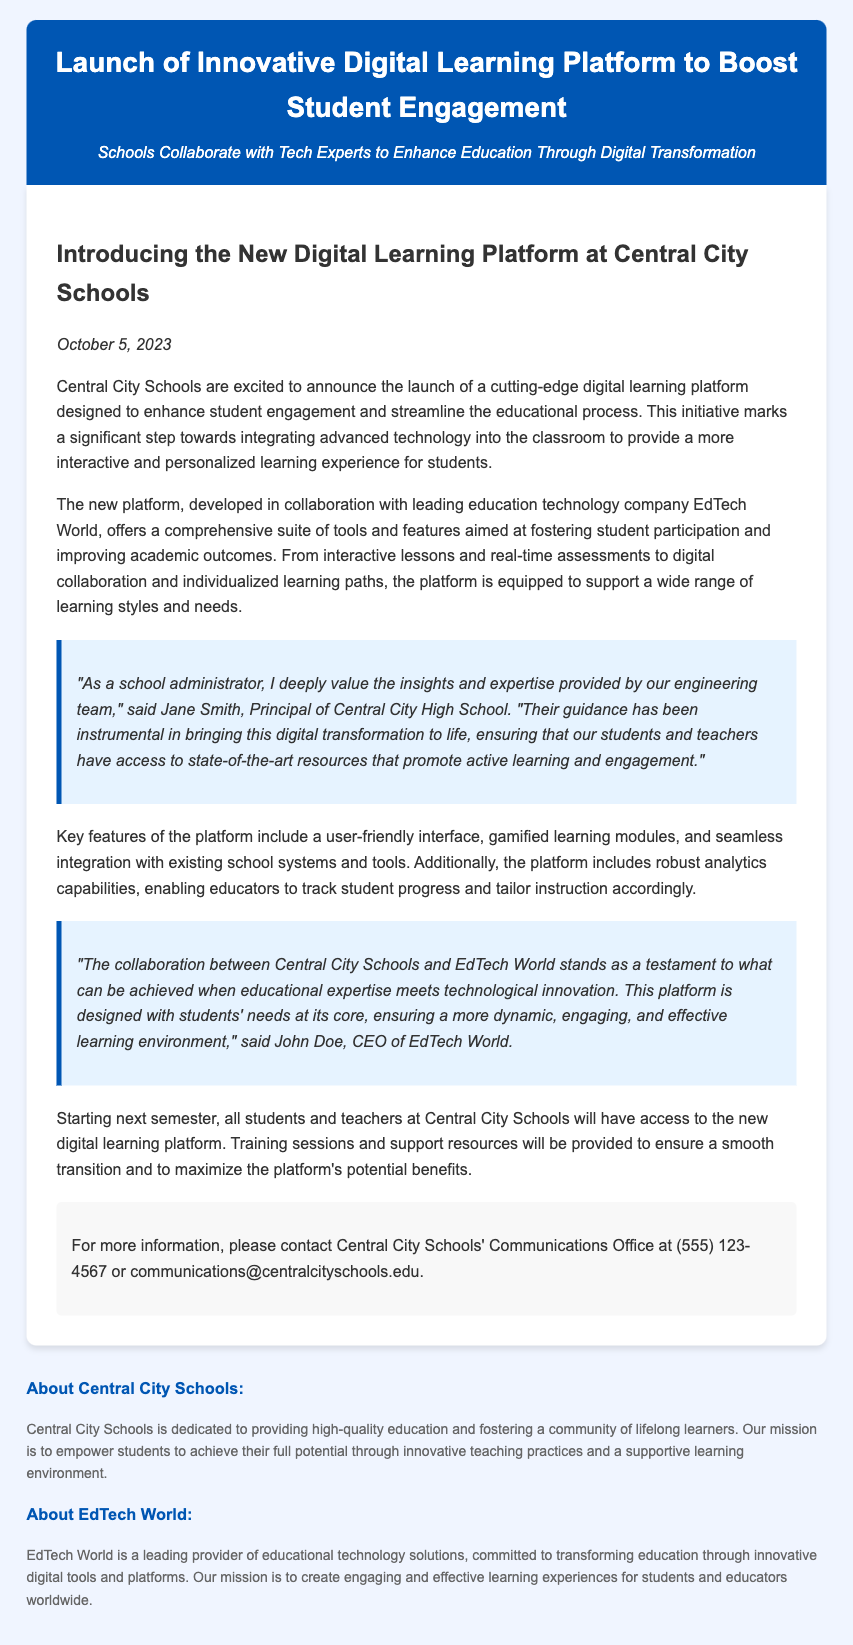What is the title of the press release? The title of the press release is explicitly given at the beginning of the document.
Answer: Launch of Innovative Digital Learning Platform to Boost Student Engagement Who developed the new digital learning platform? The document states that the platform was developed in collaboration with a specific education technology company.
Answer: EdTech World When will the new platform be accessible to students and teachers? The document mentions when the platform will be available to users within its content.
Answer: Next semester What are some key features of the platform? The document lists features that highlight the platform's capabilities, including one specific aspect.
Answer: User-friendly interface Who is the CEO of EdTech World? The press release quotes an individual holding a prominent position at EdTech World.
Answer: John Doe What is the mission of Central City Schools? The press release includes a statement about the overall mission of the school district at the end.
Answer: To empower students to achieve their full potential Why was the digital learning platform created? The document explains that the platform aims to fulfill a specific need in education.
Answer: To enhance student engagement What type of resources will be provided for the platform transition? The press release indicates what kind of support will be offered during the implementation phase.
Answer: Training sessions and support resources Who is quoted as appreciating the engineering team's guidance? The document provides a quote from a specific individual regarding engineering insights.
Answer: Jane Smith 